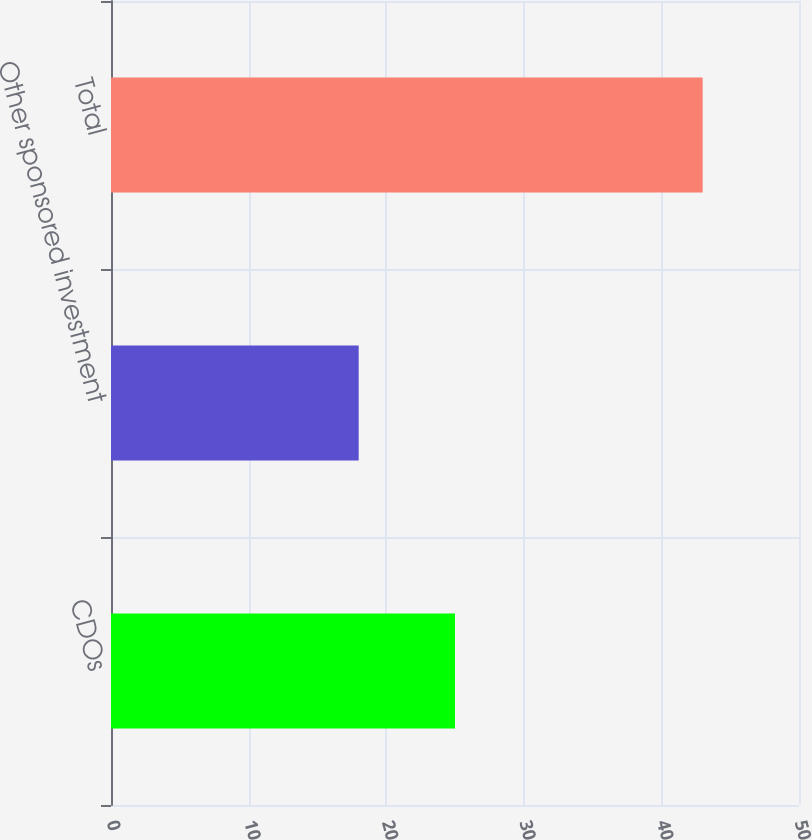Convert chart. <chart><loc_0><loc_0><loc_500><loc_500><bar_chart><fcel>CDOs<fcel>Other sponsored investment<fcel>Total<nl><fcel>25<fcel>18<fcel>43<nl></chart> 